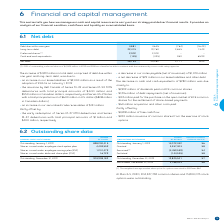According to Bce's financial document, What is the total debt comprised of? debt due within one year and long-term debt. The document states: "ase of $1,891 million in total debt, comprised of debt due within one year and long-term debt, was due to:..." Also, What is the $ change in cash and cash equivalents? According to the financial document, $280 million. The relevant text states: "The decrease in cash and cash equivalents of $280 million was due mainly to:..." Also, What is the $ change in net debt? According to the financial document, 2,171 (in millions). The relevant text states: "Net debt 28,153 25,982 2,171 8.4%..." Also, can you calculate: What is the Debt due within one year expressed as a ratio of Long-term debt for 2019? Based on the calculation: 3,881/22,415, the result is 0.17. This is based on the information: "Long-term debt 22,415 19,760 2,655 13.4% Debt due within one year 3,881 4,645 (764) (16.4%)..." The key data points involved are: 22,415, 3,881. Also, can you calculate: What is the percentage of long-term debt over net debt in 2019? Based on the calculation: 22,415/28,153, the result is 79.62 (percentage). This is based on the information: "Long-term debt 22,415 19,760 2,655 13.4% Net debt 28,153 25,982 2,171 8.4%..." The key data points involved are: 22,415, 28,153. Also, can you calculate: What is the change in the net debt in 2019? Based on the calculation: 28,153-25,982, the result is 2171 (in millions). This is based on the information: "Net debt 28,153 25,982 2,171 8.4% Net debt 28,153 25,982 2,171 8.4%..." The key data points involved are: 25,982, 28,153. 